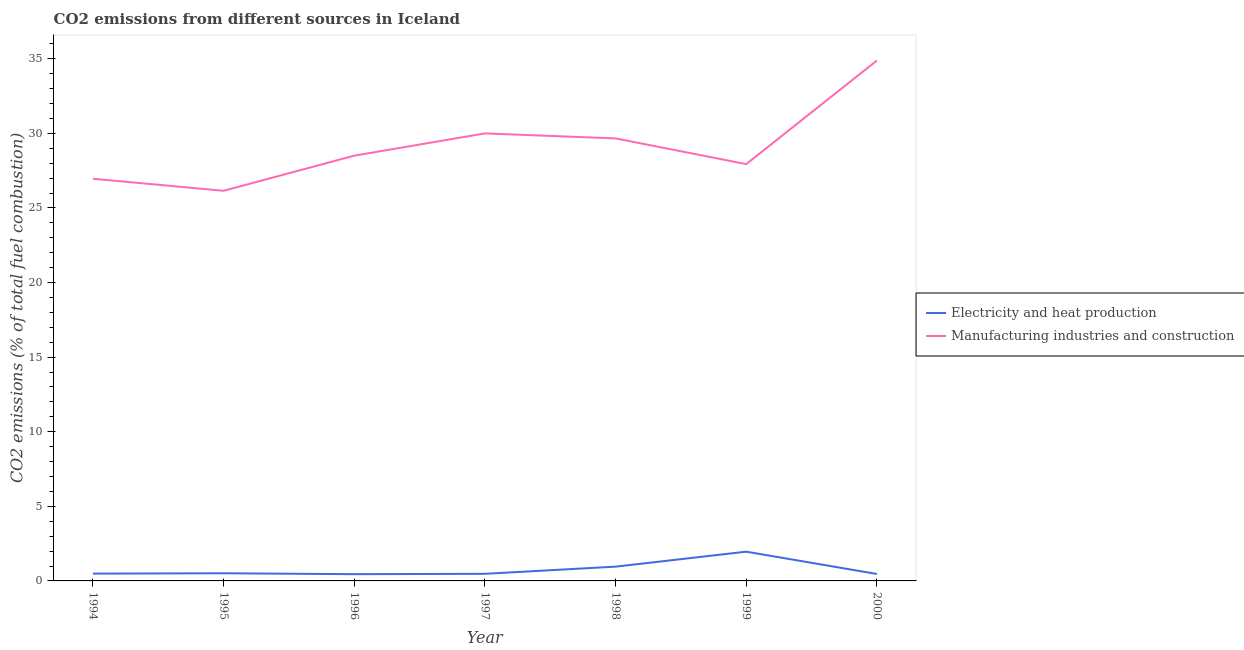How many different coloured lines are there?
Keep it short and to the point. 2. Does the line corresponding to co2 emissions due to manufacturing industries intersect with the line corresponding to co2 emissions due to electricity and heat production?
Your answer should be very brief. No. Is the number of lines equal to the number of legend labels?
Your response must be concise. Yes. What is the co2 emissions due to electricity and heat production in 1994?
Your answer should be very brief. 0.49. Across all years, what is the maximum co2 emissions due to manufacturing industries?
Provide a short and direct response. 34.88. Across all years, what is the minimum co2 emissions due to manufacturing industries?
Offer a very short reply. 26.15. In which year was the co2 emissions due to electricity and heat production minimum?
Offer a very short reply. 1996. What is the total co2 emissions due to manufacturing industries in the graph?
Your answer should be compact. 204.11. What is the difference between the co2 emissions due to electricity and heat production in 1997 and that in 1998?
Provide a succinct answer. -0.48. What is the difference between the co2 emissions due to manufacturing industries in 1999 and the co2 emissions due to electricity and heat production in 1996?
Your response must be concise. 27.49. What is the average co2 emissions due to manufacturing industries per year?
Give a very brief answer. 29.16. In the year 1997, what is the difference between the co2 emissions due to manufacturing industries and co2 emissions due to electricity and heat production?
Your answer should be very brief. 29.52. What is the ratio of the co2 emissions due to electricity and heat production in 1995 to that in 1999?
Your response must be concise. 0.26. Is the co2 emissions due to electricity and heat production in 1995 less than that in 1999?
Ensure brevity in your answer.  Yes. What is the difference between the highest and the second highest co2 emissions due to electricity and heat production?
Provide a short and direct response. 1. What is the difference between the highest and the lowest co2 emissions due to manufacturing industries?
Keep it short and to the point. 8.73. Does the co2 emissions due to manufacturing industries monotonically increase over the years?
Keep it short and to the point. No. How many lines are there?
Provide a succinct answer. 2. What is the difference between two consecutive major ticks on the Y-axis?
Your answer should be very brief. 5. Where does the legend appear in the graph?
Give a very brief answer. Center right. What is the title of the graph?
Offer a terse response. CO2 emissions from different sources in Iceland. What is the label or title of the X-axis?
Your answer should be very brief. Year. What is the label or title of the Y-axis?
Provide a short and direct response. CO2 emissions (% of total fuel combustion). What is the CO2 emissions (% of total fuel combustion) in Electricity and heat production in 1994?
Offer a terse response. 0.49. What is the CO2 emissions (% of total fuel combustion) in Manufacturing industries and construction in 1994?
Keep it short and to the point. 26.96. What is the CO2 emissions (% of total fuel combustion) of Electricity and heat production in 1995?
Your answer should be compact. 0.51. What is the CO2 emissions (% of total fuel combustion) of Manufacturing industries and construction in 1995?
Offer a very short reply. 26.15. What is the CO2 emissions (% of total fuel combustion) in Electricity and heat production in 1996?
Offer a very short reply. 0.45. What is the CO2 emissions (% of total fuel combustion) in Manufacturing industries and construction in 1996?
Your answer should be very brief. 28.51. What is the CO2 emissions (% of total fuel combustion) in Electricity and heat production in 1997?
Your answer should be compact. 0.48. What is the CO2 emissions (% of total fuel combustion) in Manufacturing industries and construction in 1997?
Provide a short and direct response. 30. What is the CO2 emissions (% of total fuel combustion) in Electricity and heat production in 1998?
Offer a very short reply. 0.96. What is the CO2 emissions (% of total fuel combustion) of Manufacturing industries and construction in 1998?
Provide a short and direct response. 29.67. What is the CO2 emissions (% of total fuel combustion) of Electricity and heat production in 1999?
Your answer should be compact. 1.96. What is the CO2 emissions (% of total fuel combustion) in Manufacturing industries and construction in 1999?
Give a very brief answer. 27.94. What is the CO2 emissions (% of total fuel combustion) of Electricity and heat production in 2000?
Your answer should be very brief. 0.47. What is the CO2 emissions (% of total fuel combustion) of Manufacturing industries and construction in 2000?
Offer a very short reply. 34.88. Across all years, what is the maximum CO2 emissions (% of total fuel combustion) in Electricity and heat production?
Your answer should be very brief. 1.96. Across all years, what is the maximum CO2 emissions (% of total fuel combustion) of Manufacturing industries and construction?
Your response must be concise. 34.88. Across all years, what is the minimum CO2 emissions (% of total fuel combustion) in Electricity and heat production?
Make the answer very short. 0.45. Across all years, what is the minimum CO2 emissions (% of total fuel combustion) in Manufacturing industries and construction?
Offer a terse response. 26.15. What is the total CO2 emissions (% of total fuel combustion) in Electricity and heat production in the graph?
Your response must be concise. 5.31. What is the total CO2 emissions (% of total fuel combustion) of Manufacturing industries and construction in the graph?
Offer a terse response. 204.11. What is the difference between the CO2 emissions (% of total fuel combustion) in Electricity and heat production in 1994 and that in 1995?
Your answer should be very brief. -0.02. What is the difference between the CO2 emissions (% of total fuel combustion) of Manufacturing industries and construction in 1994 and that in 1995?
Your answer should be compact. 0.81. What is the difference between the CO2 emissions (% of total fuel combustion) in Electricity and heat production in 1994 and that in 1996?
Make the answer very short. 0.04. What is the difference between the CO2 emissions (% of total fuel combustion) of Manufacturing industries and construction in 1994 and that in 1996?
Offer a very short reply. -1.55. What is the difference between the CO2 emissions (% of total fuel combustion) in Electricity and heat production in 1994 and that in 1997?
Your answer should be very brief. 0.01. What is the difference between the CO2 emissions (% of total fuel combustion) of Manufacturing industries and construction in 1994 and that in 1997?
Your answer should be very brief. -3.04. What is the difference between the CO2 emissions (% of total fuel combustion) of Electricity and heat production in 1994 and that in 1998?
Provide a succinct answer. -0.47. What is the difference between the CO2 emissions (% of total fuel combustion) of Manufacturing industries and construction in 1994 and that in 1998?
Keep it short and to the point. -2.7. What is the difference between the CO2 emissions (% of total fuel combustion) in Electricity and heat production in 1994 and that in 1999?
Provide a short and direct response. -1.47. What is the difference between the CO2 emissions (% of total fuel combustion) of Manufacturing industries and construction in 1994 and that in 1999?
Your answer should be very brief. -0.98. What is the difference between the CO2 emissions (% of total fuel combustion) of Electricity and heat production in 1994 and that in 2000?
Provide a succinct answer. 0.03. What is the difference between the CO2 emissions (% of total fuel combustion) in Manufacturing industries and construction in 1994 and that in 2000?
Offer a very short reply. -7.92. What is the difference between the CO2 emissions (% of total fuel combustion) of Electricity and heat production in 1995 and that in 1996?
Provide a succinct answer. 0.06. What is the difference between the CO2 emissions (% of total fuel combustion) of Manufacturing industries and construction in 1995 and that in 1996?
Your response must be concise. -2.35. What is the difference between the CO2 emissions (% of total fuel combustion) in Electricity and heat production in 1995 and that in 1997?
Make the answer very short. 0.04. What is the difference between the CO2 emissions (% of total fuel combustion) of Manufacturing industries and construction in 1995 and that in 1997?
Your answer should be compact. -3.85. What is the difference between the CO2 emissions (% of total fuel combustion) in Electricity and heat production in 1995 and that in 1998?
Your answer should be very brief. -0.44. What is the difference between the CO2 emissions (% of total fuel combustion) in Manufacturing industries and construction in 1995 and that in 1998?
Your response must be concise. -3.51. What is the difference between the CO2 emissions (% of total fuel combustion) of Electricity and heat production in 1995 and that in 1999?
Provide a succinct answer. -1.45. What is the difference between the CO2 emissions (% of total fuel combustion) of Manufacturing industries and construction in 1995 and that in 1999?
Give a very brief answer. -1.79. What is the difference between the CO2 emissions (% of total fuel combustion) of Electricity and heat production in 1995 and that in 2000?
Offer a very short reply. 0.05. What is the difference between the CO2 emissions (% of total fuel combustion) in Manufacturing industries and construction in 1995 and that in 2000?
Ensure brevity in your answer.  -8.73. What is the difference between the CO2 emissions (% of total fuel combustion) in Electricity and heat production in 1996 and that in 1997?
Offer a very short reply. -0.02. What is the difference between the CO2 emissions (% of total fuel combustion) in Manufacturing industries and construction in 1996 and that in 1997?
Ensure brevity in your answer.  -1.49. What is the difference between the CO2 emissions (% of total fuel combustion) of Electricity and heat production in 1996 and that in 1998?
Make the answer very short. -0.5. What is the difference between the CO2 emissions (% of total fuel combustion) in Manufacturing industries and construction in 1996 and that in 1998?
Provide a short and direct response. -1.16. What is the difference between the CO2 emissions (% of total fuel combustion) of Electricity and heat production in 1996 and that in 1999?
Keep it short and to the point. -1.51. What is the difference between the CO2 emissions (% of total fuel combustion) in Manufacturing industries and construction in 1996 and that in 1999?
Make the answer very short. 0.57. What is the difference between the CO2 emissions (% of total fuel combustion) of Electricity and heat production in 1996 and that in 2000?
Provide a short and direct response. -0.01. What is the difference between the CO2 emissions (% of total fuel combustion) of Manufacturing industries and construction in 1996 and that in 2000?
Ensure brevity in your answer.  -6.38. What is the difference between the CO2 emissions (% of total fuel combustion) of Electricity and heat production in 1997 and that in 1998?
Offer a very short reply. -0.48. What is the difference between the CO2 emissions (% of total fuel combustion) in Manufacturing industries and construction in 1997 and that in 1998?
Offer a very short reply. 0.33. What is the difference between the CO2 emissions (% of total fuel combustion) of Electricity and heat production in 1997 and that in 1999?
Give a very brief answer. -1.48. What is the difference between the CO2 emissions (% of total fuel combustion) of Manufacturing industries and construction in 1997 and that in 1999?
Offer a very short reply. 2.06. What is the difference between the CO2 emissions (% of total fuel combustion) of Electricity and heat production in 1997 and that in 2000?
Provide a succinct answer. 0.01. What is the difference between the CO2 emissions (% of total fuel combustion) of Manufacturing industries and construction in 1997 and that in 2000?
Provide a short and direct response. -4.88. What is the difference between the CO2 emissions (% of total fuel combustion) of Electricity and heat production in 1998 and that in 1999?
Keep it short and to the point. -1. What is the difference between the CO2 emissions (% of total fuel combustion) in Manufacturing industries and construction in 1998 and that in 1999?
Give a very brief answer. 1.72. What is the difference between the CO2 emissions (% of total fuel combustion) in Electricity and heat production in 1998 and that in 2000?
Provide a succinct answer. 0.49. What is the difference between the CO2 emissions (% of total fuel combustion) in Manufacturing industries and construction in 1998 and that in 2000?
Provide a short and direct response. -5.22. What is the difference between the CO2 emissions (% of total fuel combustion) of Electricity and heat production in 1999 and that in 2000?
Your response must be concise. 1.5. What is the difference between the CO2 emissions (% of total fuel combustion) in Manufacturing industries and construction in 1999 and that in 2000?
Ensure brevity in your answer.  -6.94. What is the difference between the CO2 emissions (% of total fuel combustion) of Electricity and heat production in 1994 and the CO2 emissions (% of total fuel combustion) of Manufacturing industries and construction in 1995?
Provide a succinct answer. -25.66. What is the difference between the CO2 emissions (% of total fuel combustion) of Electricity and heat production in 1994 and the CO2 emissions (% of total fuel combustion) of Manufacturing industries and construction in 1996?
Your answer should be very brief. -28.02. What is the difference between the CO2 emissions (% of total fuel combustion) of Electricity and heat production in 1994 and the CO2 emissions (% of total fuel combustion) of Manufacturing industries and construction in 1997?
Provide a succinct answer. -29.51. What is the difference between the CO2 emissions (% of total fuel combustion) in Electricity and heat production in 1994 and the CO2 emissions (% of total fuel combustion) in Manufacturing industries and construction in 1998?
Provide a succinct answer. -29.17. What is the difference between the CO2 emissions (% of total fuel combustion) of Electricity and heat production in 1994 and the CO2 emissions (% of total fuel combustion) of Manufacturing industries and construction in 1999?
Offer a terse response. -27.45. What is the difference between the CO2 emissions (% of total fuel combustion) in Electricity and heat production in 1994 and the CO2 emissions (% of total fuel combustion) in Manufacturing industries and construction in 2000?
Your answer should be very brief. -34.39. What is the difference between the CO2 emissions (% of total fuel combustion) of Electricity and heat production in 1995 and the CO2 emissions (% of total fuel combustion) of Manufacturing industries and construction in 1996?
Keep it short and to the point. -27.99. What is the difference between the CO2 emissions (% of total fuel combustion) in Electricity and heat production in 1995 and the CO2 emissions (% of total fuel combustion) in Manufacturing industries and construction in 1997?
Give a very brief answer. -29.49. What is the difference between the CO2 emissions (% of total fuel combustion) of Electricity and heat production in 1995 and the CO2 emissions (% of total fuel combustion) of Manufacturing industries and construction in 1998?
Give a very brief answer. -29.15. What is the difference between the CO2 emissions (% of total fuel combustion) of Electricity and heat production in 1995 and the CO2 emissions (% of total fuel combustion) of Manufacturing industries and construction in 1999?
Make the answer very short. -27.43. What is the difference between the CO2 emissions (% of total fuel combustion) in Electricity and heat production in 1995 and the CO2 emissions (% of total fuel combustion) in Manufacturing industries and construction in 2000?
Provide a short and direct response. -34.37. What is the difference between the CO2 emissions (% of total fuel combustion) in Electricity and heat production in 1996 and the CO2 emissions (% of total fuel combustion) in Manufacturing industries and construction in 1997?
Ensure brevity in your answer.  -29.55. What is the difference between the CO2 emissions (% of total fuel combustion) of Electricity and heat production in 1996 and the CO2 emissions (% of total fuel combustion) of Manufacturing industries and construction in 1998?
Your answer should be compact. -29.21. What is the difference between the CO2 emissions (% of total fuel combustion) of Electricity and heat production in 1996 and the CO2 emissions (% of total fuel combustion) of Manufacturing industries and construction in 1999?
Make the answer very short. -27.49. What is the difference between the CO2 emissions (% of total fuel combustion) in Electricity and heat production in 1996 and the CO2 emissions (% of total fuel combustion) in Manufacturing industries and construction in 2000?
Offer a terse response. -34.43. What is the difference between the CO2 emissions (% of total fuel combustion) in Electricity and heat production in 1997 and the CO2 emissions (% of total fuel combustion) in Manufacturing industries and construction in 1998?
Offer a very short reply. -29.19. What is the difference between the CO2 emissions (% of total fuel combustion) of Electricity and heat production in 1997 and the CO2 emissions (% of total fuel combustion) of Manufacturing industries and construction in 1999?
Your response must be concise. -27.46. What is the difference between the CO2 emissions (% of total fuel combustion) of Electricity and heat production in 1997 and the CO2 emissions (% of total fuel combustion) of Manufacturing industries and construction in 2000?
Offer a very short reply. -34.41. What is the difference between the CO2 emissions (% of total fuel combustion) of Electricity and heat production in 1998 and the CO2 emissions (% of total fuel combustion) of Manufacturing industries and construction in 1999?
Provide a short and direct response. -26.98. What is the difference between the CO2 emissions (% of total fuel combustion) of Electricity and heat production in 1998 and the CO2 emissions (% of total fuel combustion) of Manufacturing industries and construction in 2000?
Provide a short and direct response. -33.93. What is the difference between the CO2 emissions (% of total fuel combustion) in Electricity and heat production in 1999 and the CO2 emissions (% of total fuel combustion) in Manufacturing industries and construction in 2000?
Keep it short and to the point. -32.92. What is the average CO2 emissions (% of total fuel combustion) in Electricity and heat production per year?
Offer a very short reply. 0.76. What is the average CO2 emissions (% of total fuel combustion) in Manufacturing industries and construction per year?
Offer a terse response. 29.16. In the year 1994, what is the difference between the CO2 emissions (% of total fuel combustion) in Electricity and heat production and CO2 emissions (% of total fuel combustion) in Manufacturing industries and construction?
Your response must be concise. -26.47. In the year 1995, what is the difference between the CO2 emissions (% of total fuel combustion) in Electricity and heat production and CO2 emissions (% of total fuel combustion) in Manufacturing industries and construction?
Offer a very short reply. -25.64. In the year 1996, what is the difference between the CO2 emissions (% of total fuel combustion) in Electricity and heat production and CO2 emissions (% of total fuel combustion) in Manufacturing industries and construction?
Your response must be concise. -28.05. In the year 1997, what is the difference between the CO2 emissions (% of total fuel combustion) of Electricity and heat production and CO2 emissions (% of total fuel combustion) of Manufacturing industries and construction?
Your response must be concise. -29.52. In the year 1998, what is the difference between the CO2 emissions (% of total fuel combustion) of Electricity and heat production and CO2 emissions (% of total fuel combustion) of Manufacturing industries and construction?
Your answer should be very brief. -28.71. In the year 1999, what is the difference between the CO2 emissions (% of total fuel combustion) of Electricity and heat production and CO2 emissions (% of total fuel combustion) of Manufacturing industries and construction?
Offer a very short reply. -25.98. In the year 2000, what is the difference between the CO2 emissions (% of total fuel combustion) of Electricity and heat production and CO2 emissions (% of total fuel combustion) of Manufacturing industries and construction?
Provide a succinct answer. -34.42. What is the ratio of the CO2 emissions (% of total fuel combustion) in Electricity and heat production in 1994 to that in 1995?
Give a very brief answer. 0.96. What is the ratio of the CO2 emissions (% of total fuel combustion) of Manufacturing industries and construction in 1994 to that in 1995?
Ensure brevity in your answer.  1.03. What is the ratio of the CO2 emissions (% of total fuel combustion) in Manufacturing industries and construction in 1994 to that in 1996?
Offer a terse response. 0.95. What is the ratio of the CO2 emissions (% of total fuel combustion) in Electricity and heat production in 1994 to that in 1997?
Your response must be concise. 1.03. What is the ratio of the CO2 emissions (% of total fuel combustion) of Manufacturing industries and construction in 1994 to that in 1997?
Your answer should be very brief. 0.9. What is the ratio of the CO2 emissions (% of total fuel combustion) in Electricity and heat production in 1994 to that in 1998?
Provide a succinct answer. 0.51. What is the ratio of the CO2 emissions (% of total fuel combustion) in Manufacturing industries and construction in 1994 to that in 1998?
Offer a terse response. 0.91. What is the ratio of the CO2 emissions (% of total fuel combustion) in Manufacturing industries and construction in 1994 to that in 1999?
Your answer should be compact. 0.96. What is the ratio of the CO2 emissions (% of total fuel combustion) in Electricity and heat production in 1994 to that in 2000?
Your response must be concise. 1.05. What is the ratio of the CO2 emissions (% of total fuel combustion) of Manufacturing industries and construction in 1994 to that in 2000?
Ensure brevity in your answer.  0.77. What is the ratio of the CO2 emissions (% of total fuel combustion) in Electricity and heat production in 1995 to that in 1996?
Your answer should be compact. 1.13. What is the ratio of the CO2 emissions (% of total fuel combustion) of Manufacturing industries and construction in 1995 to that in 1996?
Provide a short and direct response. 0.92. What is the ratio of the CO2 emissions (% of total fuel combustion) in Electricity and heat production in 1995 to that in 1997?
Provide a short and direct response. 1.08. What is the ratio of the CO2 emissions (% of total fuel combustion) in Manufacturing industries and construction in 1995 to that in 1997?
Ensure brevity in your answer.  0.87. What is the ratio of the CO2 emissions (% of total fuel combustion) of Electricity and heat production in 1995 to that in 1998?
Offer a very short reply. 0.54. What is the ratio of the CO2 emissions (% of total fuel combustion) of Manufacturing industries and construction in 1995 to that in 1998?
Make the answer very short. 0.88. What is the ratio of the CO2 emissions (% of total fuel combustion) in Electricity and heat production in 1995 to that in 1999?
Your answer should be compact. 0.26. What is the ratio of the CO2 emissions (% of total fuel combustion) in Manufacturing industries and construction in 1995 to that in 1999?
Make the answer very short. 0.94. What is the ratio of the CO2 emissions (% of total fuel combustion) of Electricity and heat production in 1995 to that in 2000?
Offer a very short reply. 1.1. What is the ratio of the CO2 emissions (% of total fuel combustion) of Manufacturing industries and construction in 1995 to that in 2000?
Provide a succinct answer. 0.75. What is the ratio of the CO2 emissions (% of total fuel combustion) of Electricity and heat production in 1996 to that in 1997?
Your answer should be compact. 0.95. What is the ratio of the CO2 emissions (% of total fuel combustion) of Manufacturing industries and construction in 1996 to that in 1997?
Offer a very short reply. 0.95. What is the ratio of the CO2 emissions (% of total fuel combustion) in Electricity and heat production in 1996 to that in 1998?
Your answer should be very brief. 0.47. What is the ratio of the CO2 emissions (% of total fuel combustion) of Manufacturing industries and construction in 1996 to that in 1998?
Make the answer very short. 0.96. What is the ratio of the CO2 emissions (% of total fuel combustion) of Electricity and heat production in 1996 to that in 1999?
Your response must be concise. 0.23. What is the ratio of the CO2 emissions (% of total fuel combustion) in Manufacturing industries and construction in 1996 to that in 1999?
Offer a terse response. 1.02. What is the ratio of the CO2 emissions (% of total fuel combustion) in Electricity and heat production in 1996 to that in 2000?
Ensure brevity in your answer.  0.97. What is the ratio of the CO2 emissions (% of total fuel combustion) of Manufacturing industries and construction in 1996 to that in 2000?
Give a very brief answer. 0.82. What is the ratio of the CO2 emissions (% of total fuel combustion) of Electricity and heat production in 1997 to that in 1998?
Give a very brief answer. 0.5. What is the ratio of the CO2 emissions (% of total fuel combustion) of Manufacturing industries and construction in 1997 to that in 1998?
Offer a very short reply. 1.01. What is the ratio of the CO2 emissions (% of total fuel combustion) in Electricity and heat production in 1997 to that in 1999?
Your answer should be compact. 0.24. What is the ratio of the CO2 emissions (% of total fuel combustion) in Manufacturing industries and construction in 1997 to that in 1999?
Keep it short and to the point. 1.07. What is the ratio of the CO2 emissions (% of total fuel combustion) of Electricity and heat production in 1997 to that in 2000?
Provide a succinct answer. 1.02. What is the ratio of the CO2 emissions (% of total fuel combustion) in Manufacturing industries and construction in 1997 to that in 2000?
Make the answer very short. 0.86. What is the ratio of the CO2 emissions (% of total fuel combustion) of Electricity and heat production in 1998 to that in 1999?
Your answer should be compact. 0.49. What is the ratio of the CO2 emissions (% of total fuel combustion) of Manufacturing industries and construction in 1998 to that in 1999?
Make the answer very short. 1.06. What is the ratio of the CO2 emissions (% of total fuel combustion) of Electricity and heat production in 1998 to that in 2000?
Give a very brief answer. 2.06. What is the ratio of the CO2 emissions (% of total fuel combustion) in Manufacturing industries and construction in 1998 to that in 2000?
Provide a short and direct response. 0.85. What is the ratio of the CO2 emissions (% of total fuel combustion) of Electricity and heat production in 1999 to that in 2000?
Your response must be concise. 4.22. What is the ratio of the CO2 emissions (% of total fuel combustion) in Manufacturing industries and construction in 1999 to that in 2000?
Make the answer very short. 0.8. What is the difference between the highest and the second highest CO2 emissions (% of total fuel combustion) of Manufacturing industries and construction?
Offer a very short reply. 4.88. What is the difference between the highest and the lowest CO2 emissions (% of total fuel combustion) in Electricity and heat production?
Ensure brevity in your answer.  1.51. What is the difference between the highest and the lowest CO2 emissions (% of total fuel combustion) in Manufacturing industries and construction?
Make the answer very short. 8.73. 